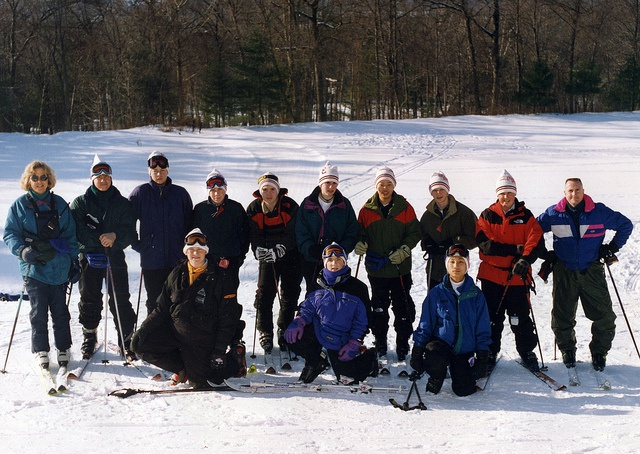Describe the objects in this image and their specific colors. I can see people in black, navy, lightgray, and darkgray tones, people in black, gray, maroon, and brown tones, people in black, navy, blue, and gray tones, people in black, navy, gray, and blue tones, and people in black, gray, lightgray, and darkgray tones in this image. 